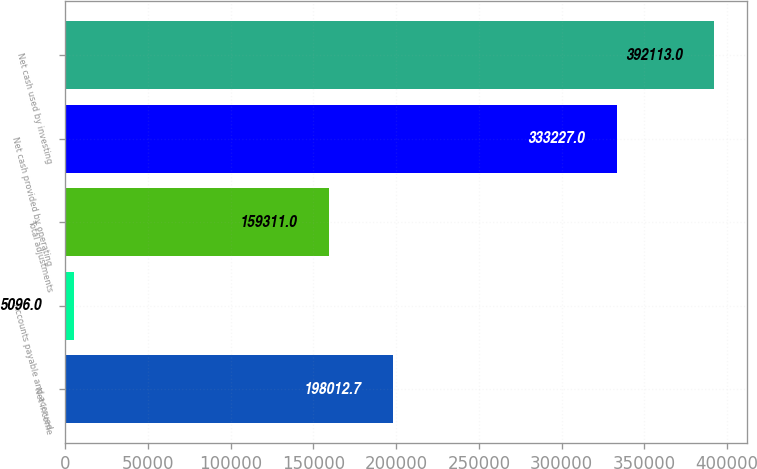Convert chart to OTSL. <chart><loc_0><loc_0><loc_500><loc_500><bar_chart><fcel>Net income<fcel>Accounts payable and accrued<fcel>Total adjustments<fcel>Net cash provided by operating<fcel>Net cash used by investing<nl><fcel>198013<fcel>5096<fcel>159311<fcel>333227<fcel>392113<nl></chart> 